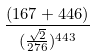Convert formula to latex. <formula><loc_0><loc_0><loc_500><loc_500>\frac { ( 1 6 7 + 4 4 6 ) } { ( \frac { \sqrt { 2 } } { 2 7 6 } ) ^ { 4 4 3 } }</formula> 